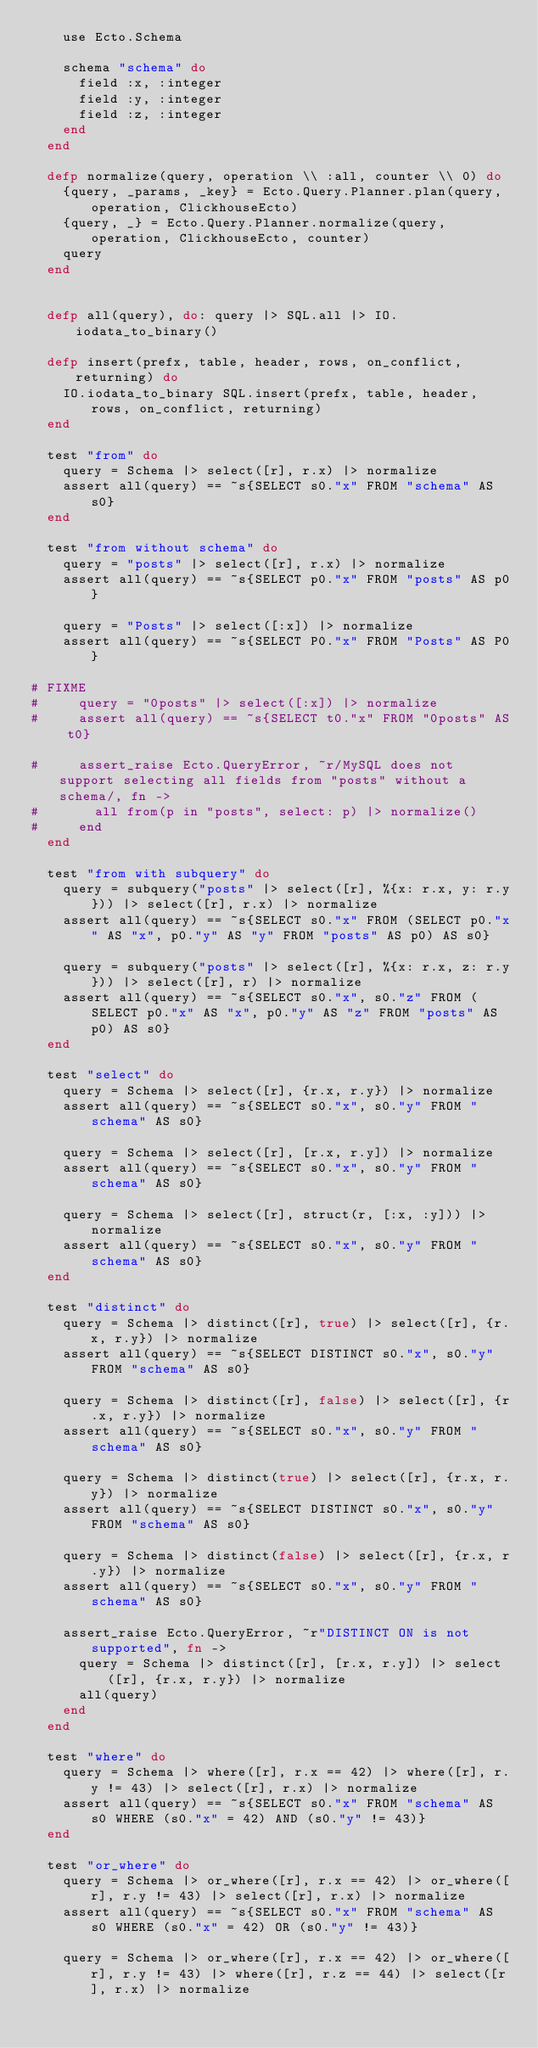Convert code to text. <code><loc_0><loc_0><loc_500><loc_500><_Elixir_>    use Ecto.Schema

    schema "schema" do
      field :x, :integer
      field :y, :integer
      field :z, :integer
    end
  end

  defp normalize(query, operation \\ :all, counter \\ 0) do
    {query, _params, _key} = Ecto.Query.Planner.plan(query, operation, ClickhouseEcto)
    {query, _} = Ecto.Query.Planner.normalize(query, operation, ClickhouseEcto, counter)
    query
  end


  defp all(query), do: query |> SQL.all |> IO.iodata_to_binary()

  defp insert(prefx, table, header, rows, on_conflict, returning) do
    IO.iodata_to_binary SQL.insert(prefx, table, header, rows, on_conflict, returning)
  end

  test "from" do
    query = Schema |> select([r], r.x) |> normalize
    assert all(query) == ~s{SELECT s0."x" FROM "schema" AS s0}
  end

  test "from without schema" do
    query = "posts" |> select([r], r.x) |> normalize
    assert all(query) == ~s{SELECT p0."x" FROM "posts" AS p0}

    query = "Posts" |> select([:x]) |> normalize
    assert all(query) == ~s{SELECT P0."x" FROM "Posts" AS P0}

# FIXME
#     query = "0posts" |> select([:x]) |> normalize
#     assert all(query) == ~s{SELECT t0."x" FROM "0posts" AS t0}

#     assert_raise Ecto.QueryError, ~r/MySQL does not support selecting all fields from "posts" without a schema/, fn ->
#       all from(p in "posts", select: p) |> normalize()
#     end
  end

  test "from with subquery" do
    query = subquery("posts" |> select([r], %{x: r.x, y: r.y})) |> select([r], r.x) |> normalize
    assert all(query) == ~s{SELECT s0."x" FROM (SELECT p0."x" AS "x", p0."y" AS "y" FROM "posts" AS p0) AS s0}

    query = subquery("posts" |> select([r], %{x: r.x, z: r.y})) |> select([r], r) |> normalize
    assert all(query) == ~s{SELECT s0."x", s0."z" FROM (SELECT p0."x" AS "x", p0."y" AS "z" FROM "posts" AS p0) AS s0}
  end

  test "select" do
    query = Schema |> select([r], {r.x, r.y}) |> normalize
    assert all(query) == ~s{SELECT s0."x", s0."y" FROM "schema" AS s0}

    query = Schema |> select([r], [r.x, r.y]) |> normalize
    assert all(query) == ~s{SELECT s0."x", s0."y" FROM "schema" AS s0}

    query = Schema |> select([r], struct(r, [:x, :y])) |> normalize
    assert all(query) == ~s{SELECT s0."x", s0."y" FROM "schema" AS s0}
  end

  test "distinct" do
    query = Schema |> distinct([r], true) |> select([r], {r.x, r.y}) |> normalize
    assert all(query) == ~s{SELECT DISTINCT s0."x", s0."y" FROM "schema" AS s0}

    query = Schema |> distinct([r], false) |> select([r], {r.x, r.y}) |> normalize
    assert all(query) == ~s{SELECT s0."x", s0."y" FROM "schema" AS s0}

    query = Schema |> distinct(true) |> select([r], {r.x, r.y}) |> normalize
    assert all(query) == ~s{SELECT DISTINCT s0."x", s0."y" FROM "schema" AS s0}

    query = Schema |> distinct(false) |> select([r], {r.x, r.y}) |> normalize
    assert all(query) == ~s{SELECT s0."x", s0."y" FROM "schema" AS s0}

    assert_raise Ecto.QueryError, ~r"DISTINCT ON is not supported", fn ->
      query = Schema |> distinct([r], [r.x, r.y]) |> select([r], {r.x, r.y}) |> normalize
      all(query)
    end
  end

  test "where" do
    query = Schema |> where([r], r.x == 42) |> where([r], r.y != 43) |> select([r], r.x) |> normalize
    assert all(query) == ~s{SELECT s0."x" FROM "schema" AS s0 WHERE (s0."x" = 42) AND (s0."y" != 43)}
  end

  test "or_where" do
    query = Schema |> or_where([r], r.x == 42) |> or_where([r], r.y != 43) |> select([r], r.x) |> normalize
    assert all(query) == ~s{SELECT s0."x" FROM "schema" AS s0 WHERE (s0."x" = 42) OR (s0."y" != 43)}

    query = Schema |> or_where([r], r.x == 42) |> or_where([r], r.y != 43) |> where([r], r.z == 44) |> select([r], r.x) |> normalize</code> 